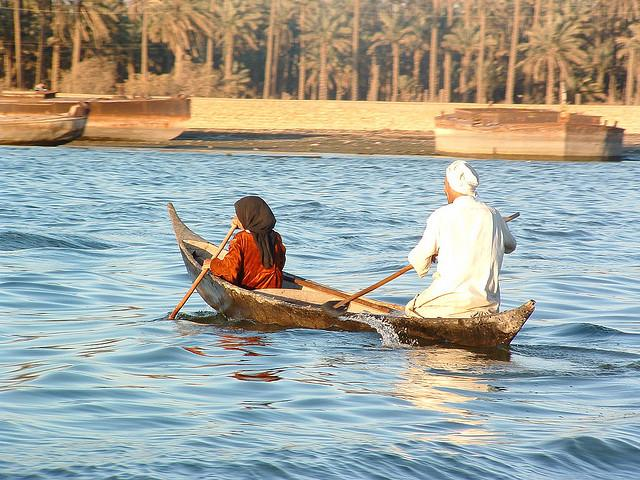What do the people have in their hands? oars 